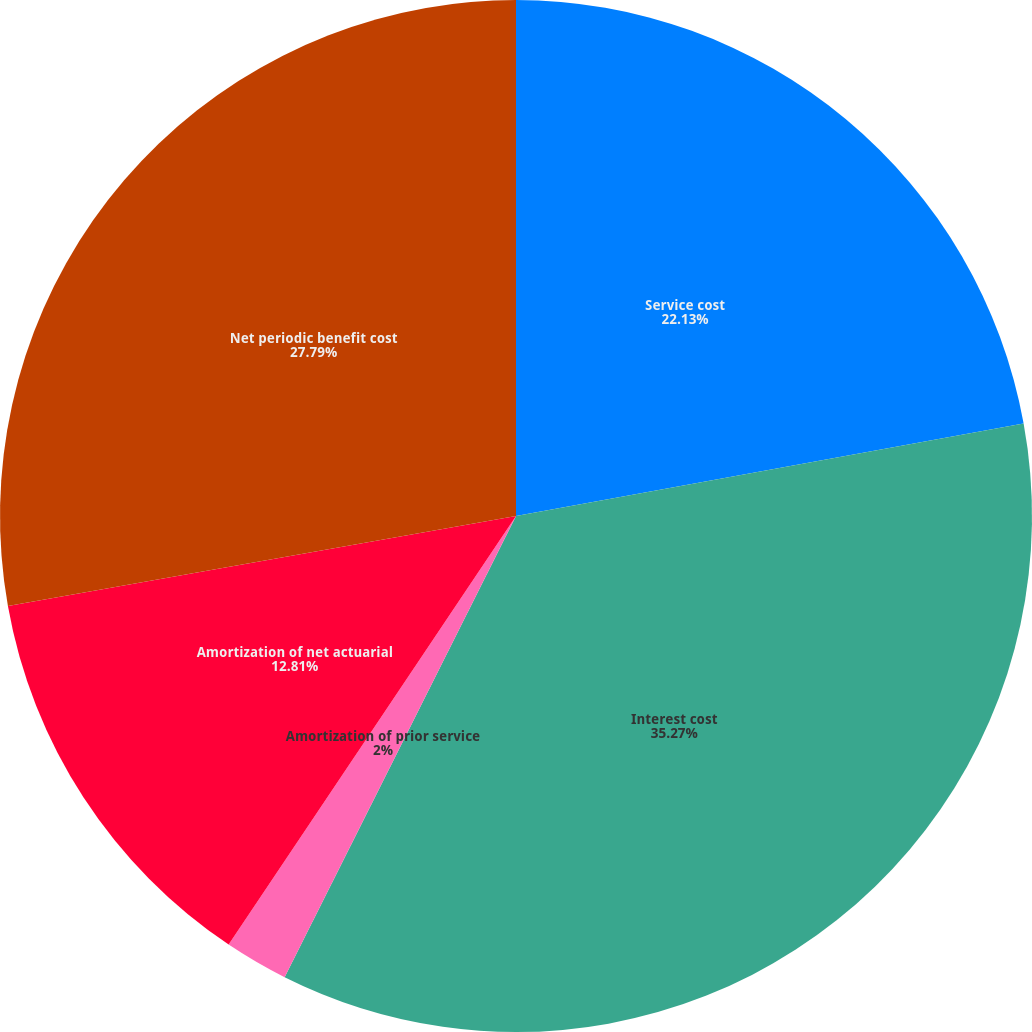<chart> <loc_0><loc_0><loc_500><loc_500><pie_chart><fcel>Service cost<fcel>Interest cost<fcel>Amortization of prior service<fcel>Amortization of net actuarial<fcel>Net periodic benefit cost<nl><fcel>22.13%<fcel>35.27%<fcel>2.0%<fcel>12.81%<fcel>27.79%<nl></chart> 